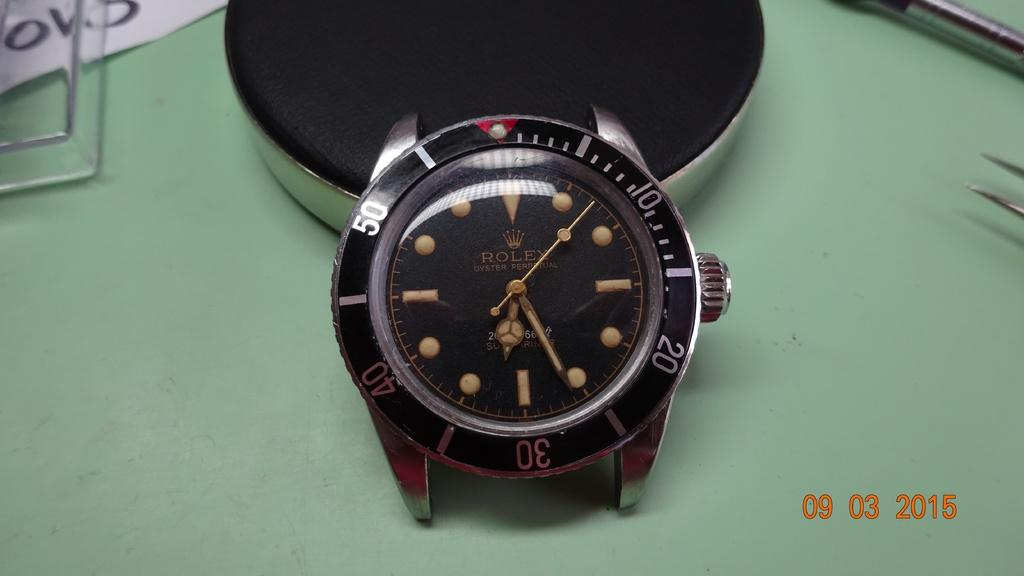Provide a one-sentence caption for the provided image. A Rolex watch with no band and no numbers on the watch face is placed on a green table. 